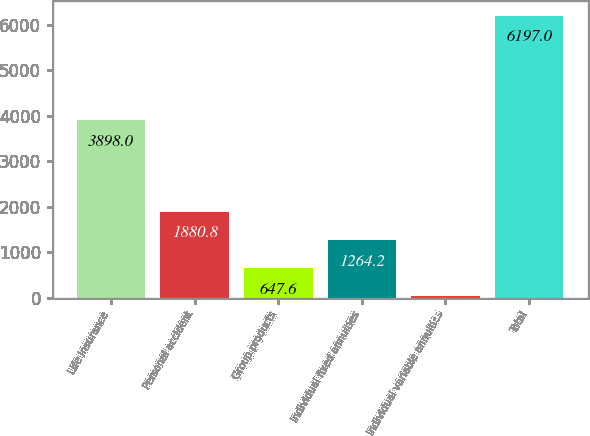Convert chart to OTSL. <chart><loc_0><loc_0><loc_500><loc_500><bar_chart><fcel>Life insurance<fcel>Personal accident<fcel>Group products<fcel>Individual fixed annuities<fcel>Individual variable annuities<fcel>Total<nl><fcel>3898<fcel>1880.8<fcel>647.6<fcel>1264.2<fcel>31<fcel>6197<nl></chart> 